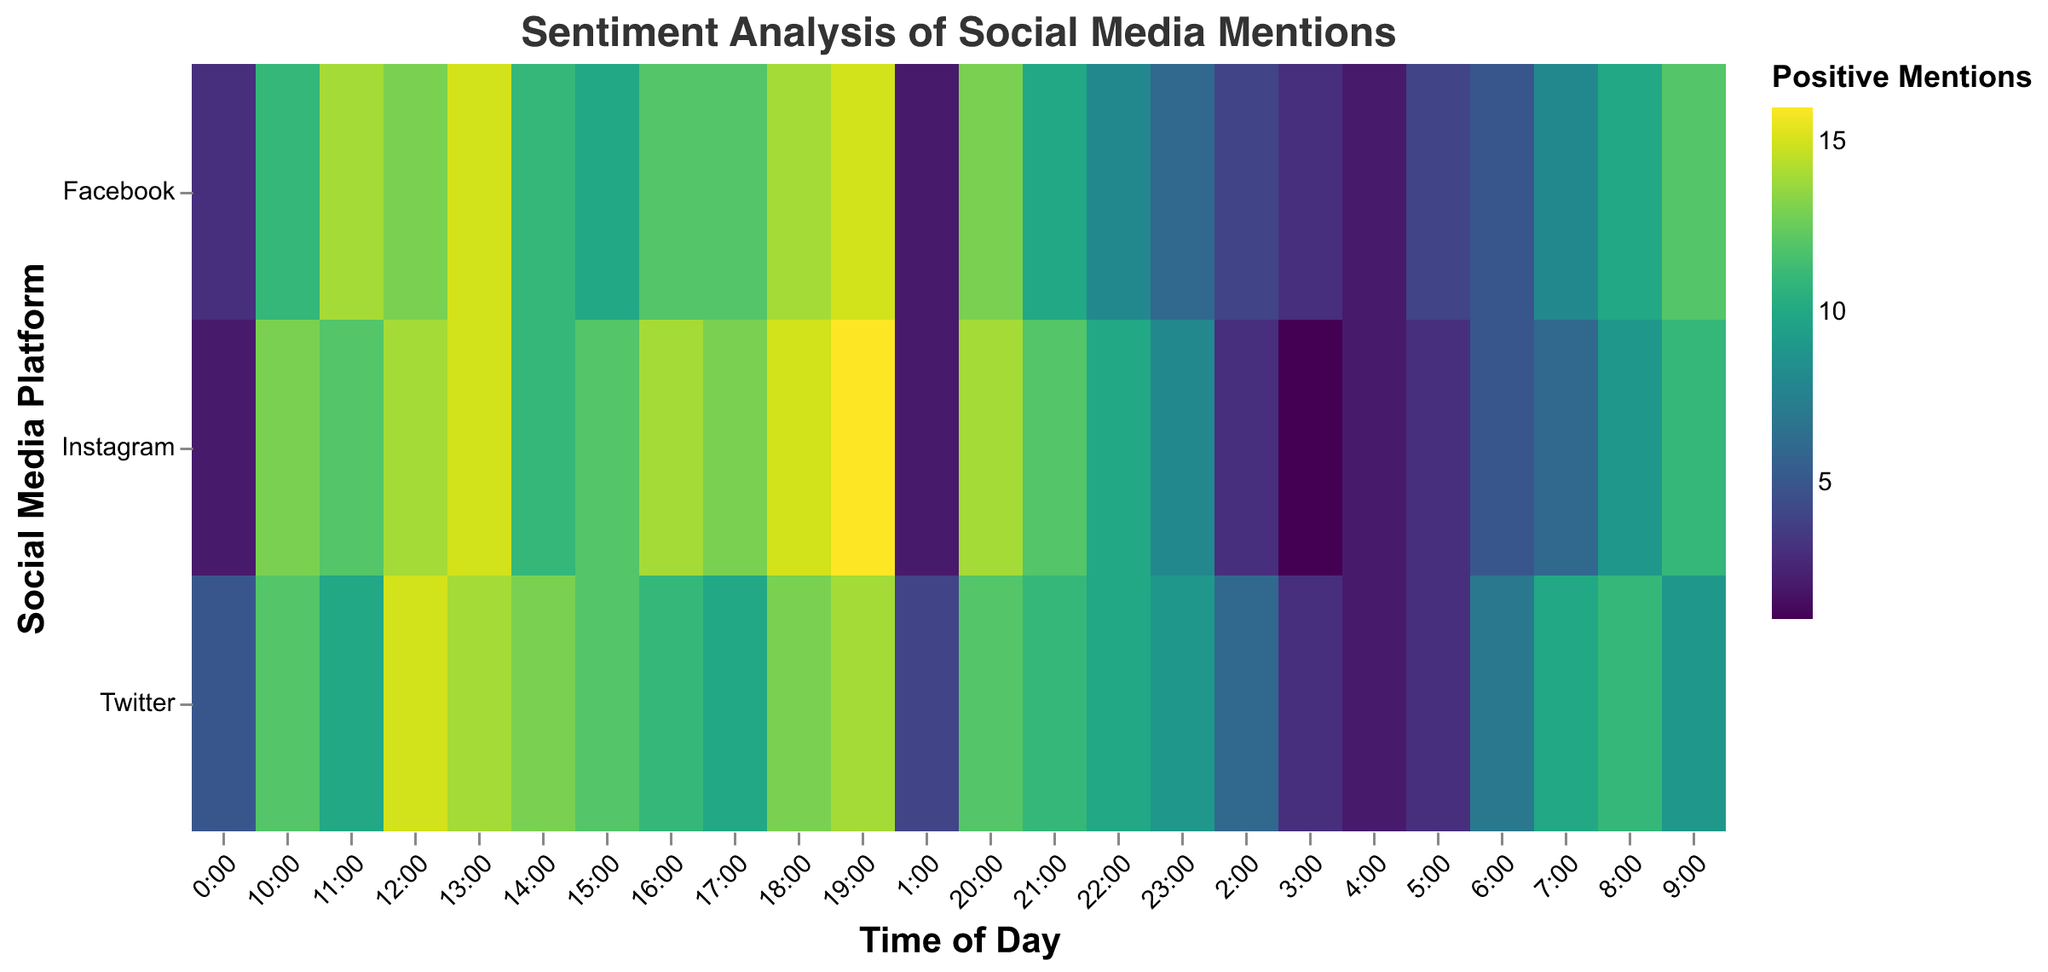What's the peak time for positive mentions on Twitter? Look for the highest number of positive mentions in the row for Twitter. The 12:00 slot has 15 positive mentions, which is the highest.
Answer: 12:00 Which platform generally has the highest positive mentions throughout the day? By observing the heatmap, Instagram displays the most consistent high positive mentions values, especially from 10:00 to 19:00.
Answer: Instagram What is the trend for neutral mentions on Facebook over the day? Checking the Facebook row, neutral mentions remain relatively low and stable but have minor peaks, without drastic changes throughout the day. The highest number is 5 which occurs at 9:00 and 17:00.
Answer: Stable with small peaks How do Instagram's positive mentions compare between 8:00 and 20:00? Look at the positive mentions for Instagram between 8:00 and 20:00. Values consistently high, especially notable is the range of 9 to 16 positive mentions in that time span.
Answer: High and consistent Is there a specific time when negative mentions peak on any platform? Though the heatmap doesn't directly highlight negative mentions, by looking at the highest peaks, we see Twitter and Facebook both peak at 4:00, with 6 and 6 negative mentions respectively.
Answer: 4:00 Which time slot has the highest variance in positive mentions across all platforms? Comparing all platforms at each time, 13:00 shows notable high values for all three (14 on Twitter, 15 on Facebook, 15 on Instagram), indicating the highest variance.
Answer: 13:00 Which platform receives the least positive mentions overall? Observing the lowest numbers across rows for different platforms, Facebook tends to have relatively lower numbers in the early morning hours and a lesser sum overall compared to Twitter and Instagram.
Answer: Facebook What time shows the most negative sentiment (negative mentions) on Instagram? Check the Instagram row for the highest negative mentions; both 1:00 and 0:00 show the highest count of 6.
Answer: 0:00 and 1:00 How does Twitter's positive sentiment at 12:00 compare to Facebook and Instagram at the same time? At 12:00, Twitter has 15 positive mentions, Facebook has 13, and Instagram also has 14. Twitter has the most positive mentions at this time.
Answer: Highest on Twitter Which social media platform has the most positive mentions at 9:00? By comparing positive mentions at 9:00, Instagram leads with 11, followed by Twitter with 9, and Facebook also has 12 mentions
Answer: Facebook What is the difference between the number of positive and negative mentions on Twitter at 10:00? At 10:00 on Twitter, there are 12 positive mentions and 0 negative mentions. The difference is 12 - 0 = 12.
Answer: 12 